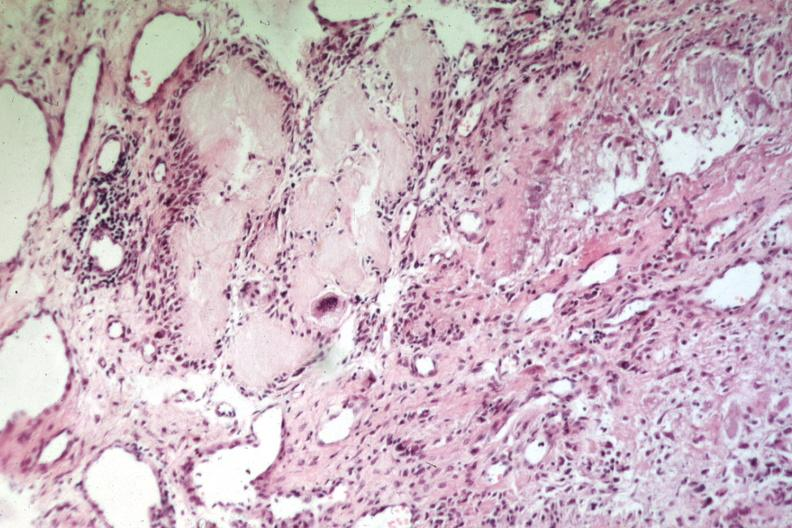how does this image show uric acid deposits?
Answer the question using a single word or phrase. With giant cells easily recognizable as gout or tophus 